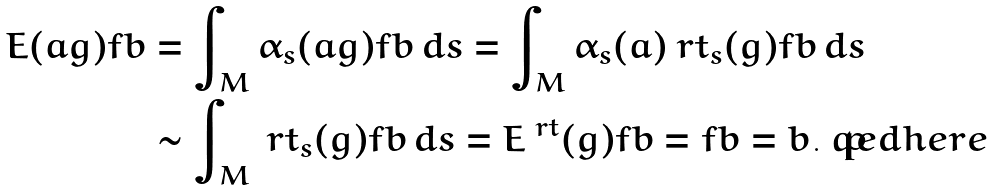<formula> <loc_0><loc_0><loc_500><loc_500>E ( a g ) f b & = \int _ { M } \alpha _ { s } ( a g ) f b \, d s = \int _ { M } \alpha _ { s } ( a ) \ r t _ { s } ( g ) f b \, d s \\ & \sim \int _ { M } \ r t _ { s } ( g ) f b \, d s = E ^ { \ r t } ( g ) f b = f b = b . \ q e d h e r e</formula> 